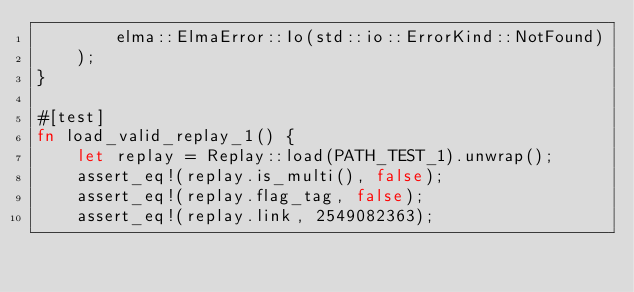<code> <loc_0><loc_0><loc_500><loc_500><_Rust_>        elma::ElmaError::Io(std::io::ErrorKind::NotFound)
    );
}

#[test]
fn load_valid_replay_1() {
    let replay = Replay::load(PATH_TEST_1).unwrap();
    assert_eq!(replay.is_multi(), false);
    assert_eq!(replay.flag_tag, false);
    assert_eq!(replay.link, 2549082363);</code> 